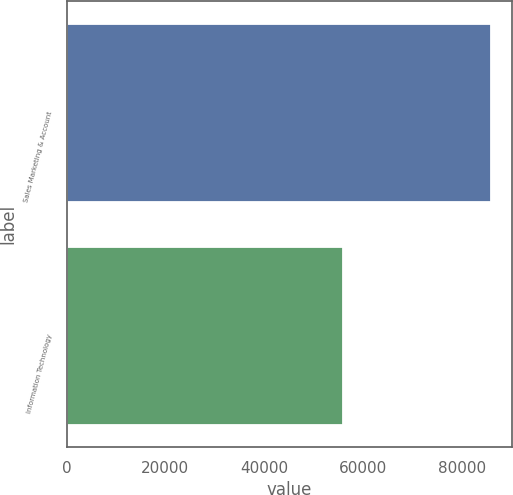<chart> <loc_0><loc_0><loc_500><loc_500><bar_chart><fcel>Sales Marketing & Account<fcel>Information Technology<nl><fcel>85932<fcel>55971<nl></chart> 